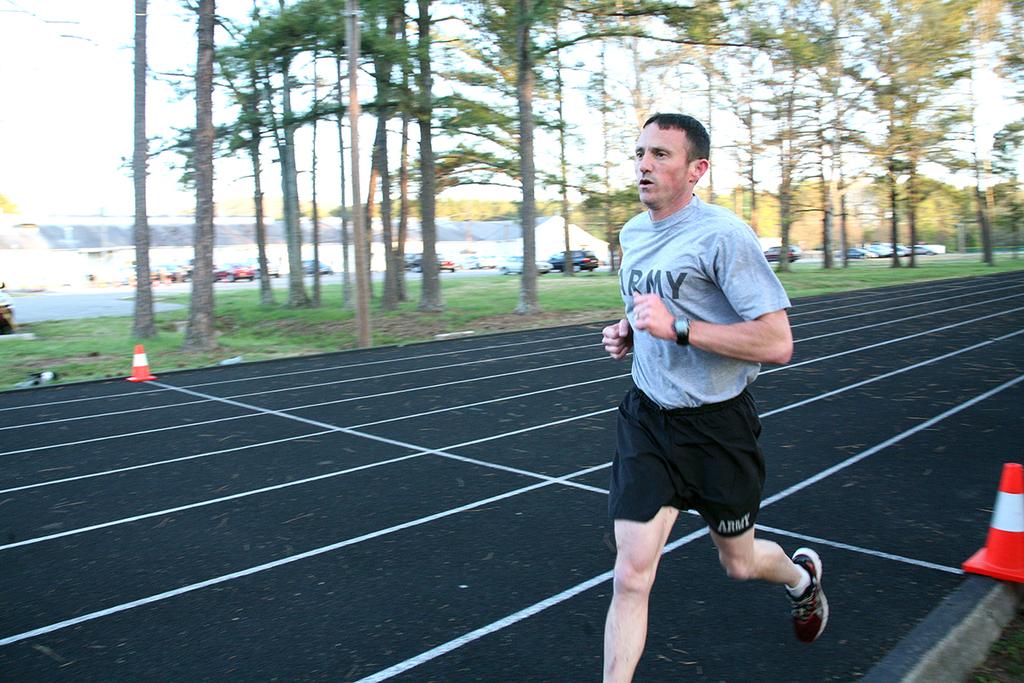What is written on the shorts?
Keep it short and to the point. Army. 